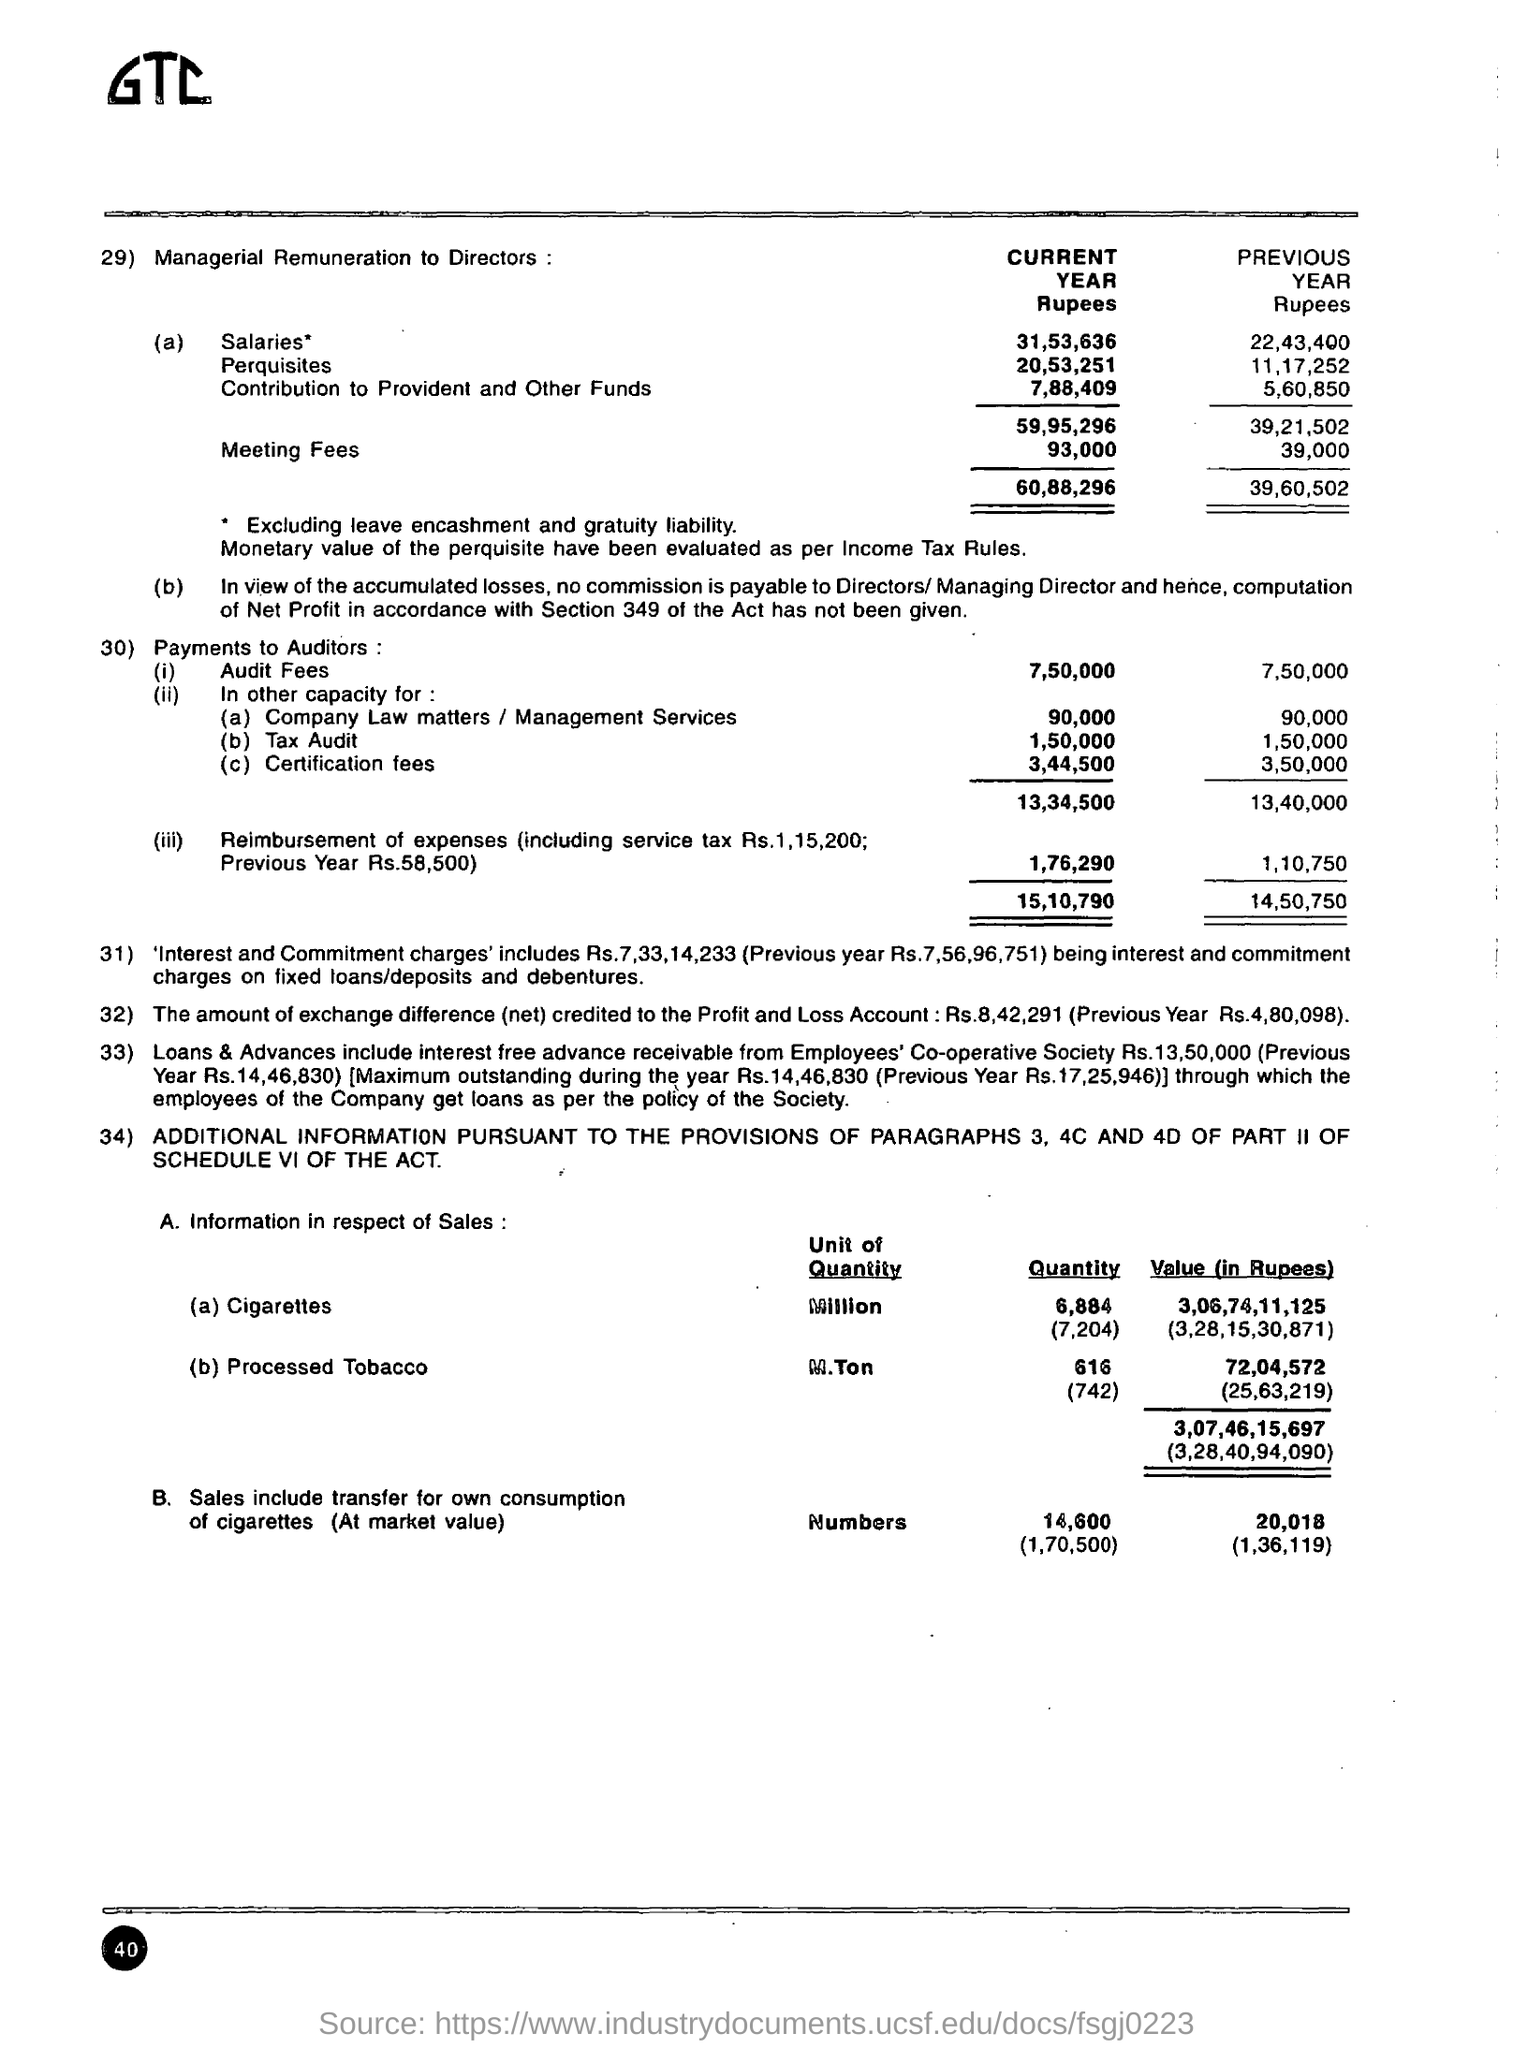Outline some significant characteristics in this image. The current year audit fees are 7,50,000. The current year certification fees are 3,44,500. The current year's meeting fees are 93,000. The previous year salaries were 22,43,400. The contribution to provident and other funds for the current year is 7,88,409. 